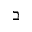Convert formula to latex. <formula><loc_0><loc_0><loc_500><loc_500>\beth</formula> 